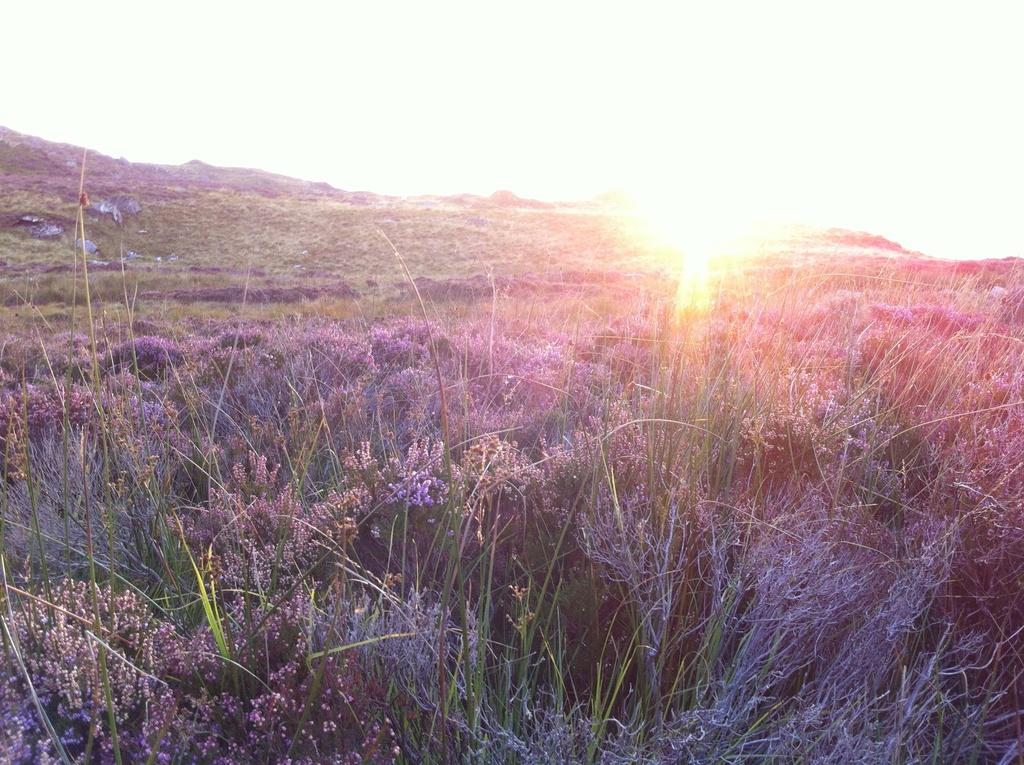What type of living organisms can be seen in the image? Plants can be seen in the image. What celestial body is visible in the background of the image? The sun is visible in the background of the image. What is the color of the sky in the background of the image? The sky appears to be white in the background of the image. What type of relationship does the daughter have with the parent in the image? There is no daughter or parent present in the image; it only features plants and the sky. 